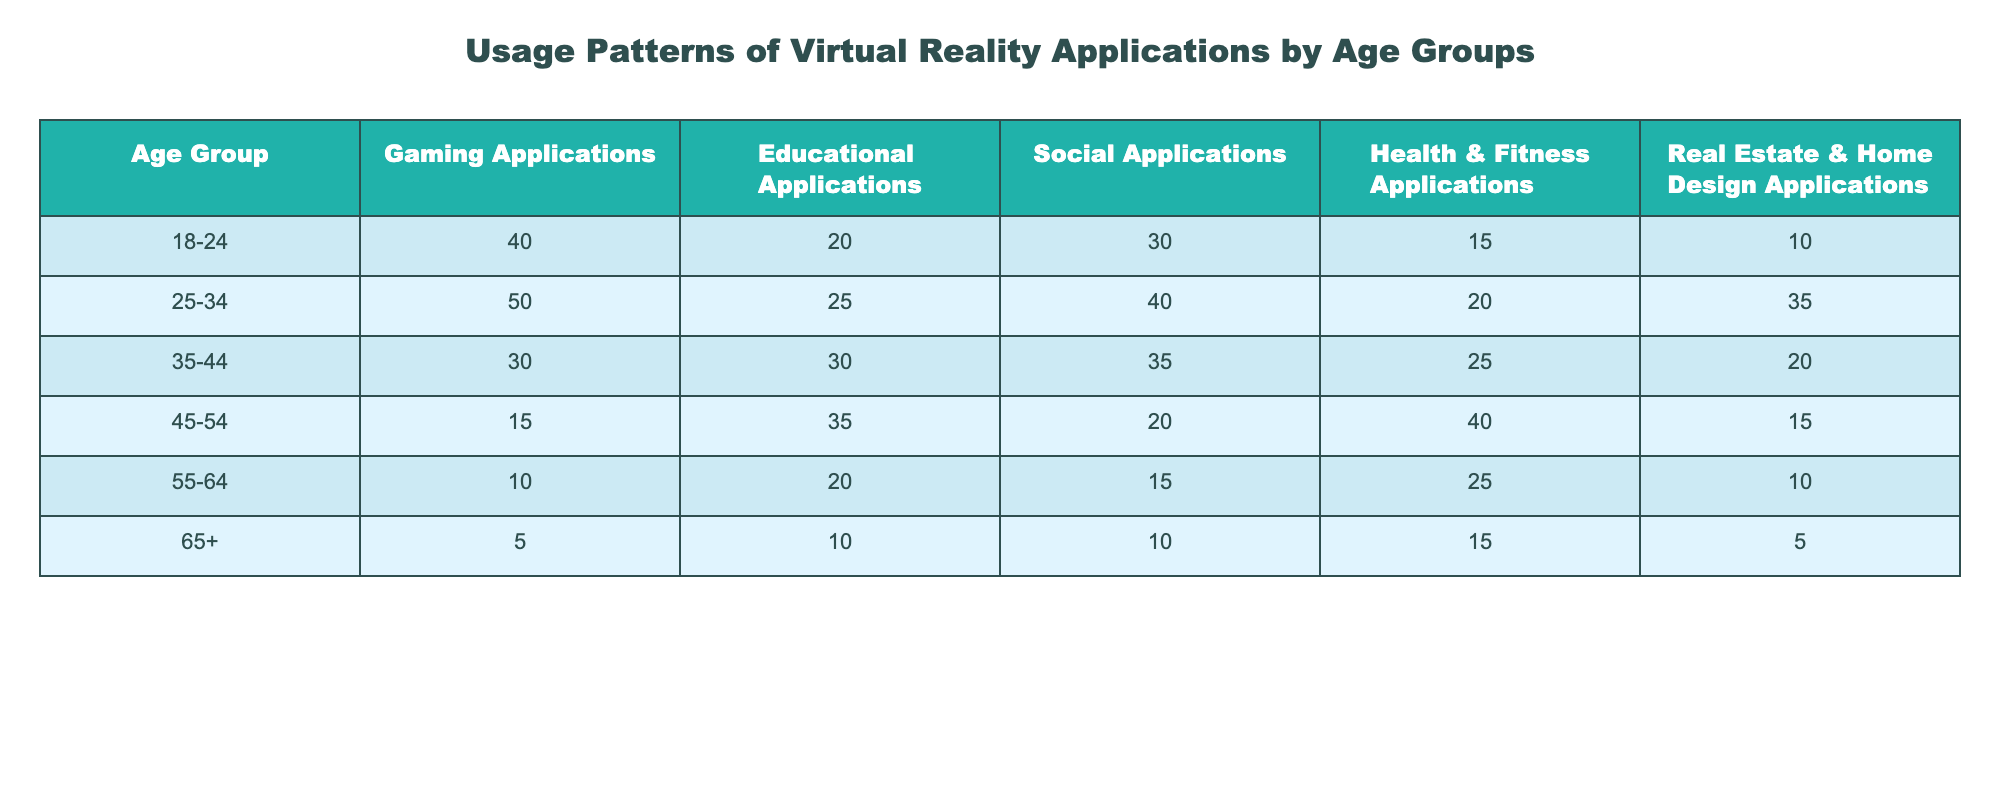What age group has the highest usage of gaming applications? Looking at the "Gaming Applications" column, the age group "25-34" has the highest value at 50.
Answer: 25-34 Which age group uses health and fitness applications the least? The age group "65+" has the lowest number of usage for "Health & Fitness Applications" at 15.
Answer: 65+ What is the total usage of educational applications across all age groups? To find the total, we sum the values for "Educational Applications": 20 + 25 + 30 + 35 + 20 + 10 = 140.
Answer: 140 Do more people in the age group 35-44 use social applications than in the age group 45-54? The age group "35-44" has 35 users for social applications while "45-54" has 20. Since 35 is greater than 20, the statement is true.
Answer: Yes What is the average usage of real estate and home design applications for the age groups 18-24 and 25-34 combined? First, calculate the total from both groups: 10 (18-24) + 35 (25-34) = 45. There are 2 age groups, so the average is 45/2 = 22.5.
Answer: 22.5 Are individuals aged 55-64 more likely to use social applications compared to those aged 65+? For "Social Applications," 55-64 has 15 while 65+ has 10. Since 15 is greater than 10, it confirms that they are more likely to use social applications.
Answer: Yes What is the difference between the highest and lowest usage of health and fitness applications across the age groups? The highest is 40 (age group 45-54) and the lowest is 15 (age group 65+). The difference is 40 - 15 = 25.
Answer: 25 What percentage of the total usage of gaming applications comes from the age group 18-24? The total gaming usage is 40 (18-24) + 50 (25-34) + 30 (35-44) + 15 (45-54) + 10 (55-64) + 5 (65+) = 150. For the age group 18-24, the percentage is (40/150)*100 = 26.67%.
Answer: 26.67% Which applications have a usage value of more than 30 in the age group 25-34? The values for the age group 25-34 are: Gaming (50), Educational (25), Social (40), Health & Fitness (20), and Real Estate (35). Only Gaming (50) and Real Estate & Home Design (35) exceed 30.
Answer: Gaming, Real Estate & Home Design 